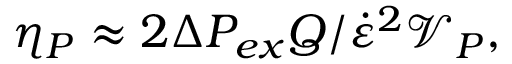<formula> <loc_0><loc_0><loc_500><loc_500>\eta _ { P } \approx 2 \Delta P _ { e x } Q / \dot { \varepsilon } ^ { 2 } \mathcal { V } _ { P } ,</formula> 